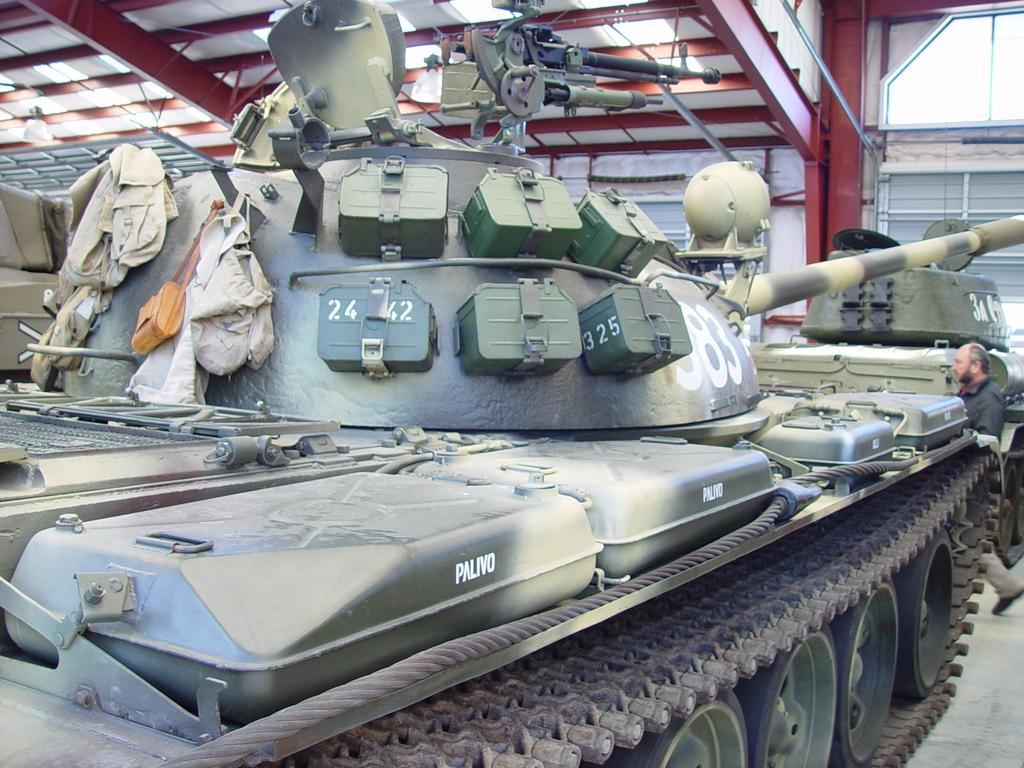Could you give a brief overview of what you see in this image? In this image I can see a battle tank is in green color. On the right side a man is walking, at the top it is the iron roof. 